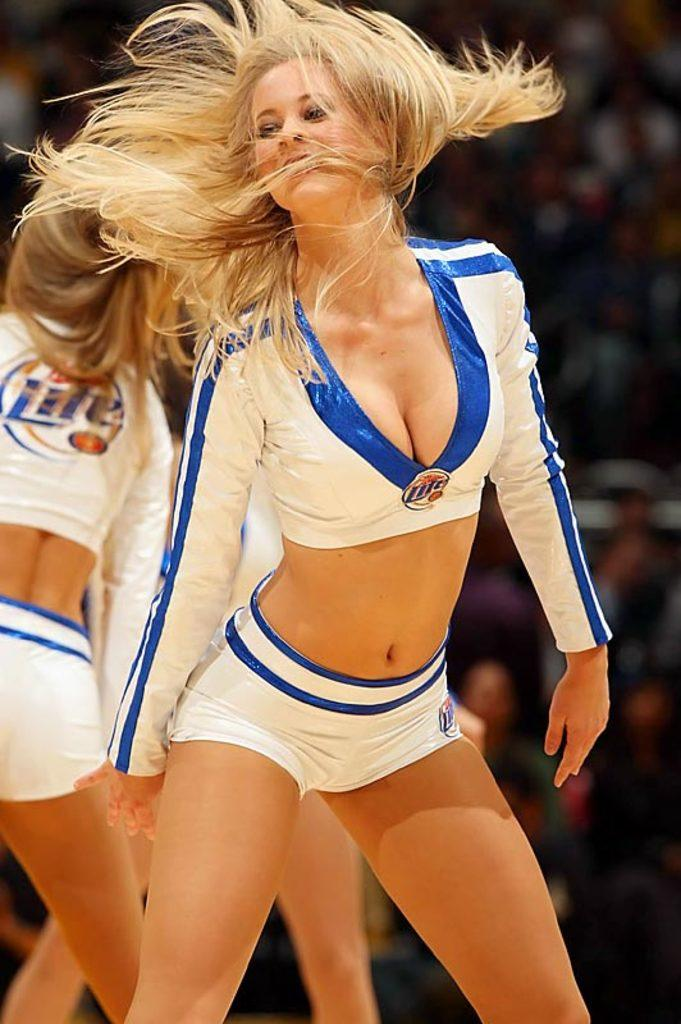<image>
Write a terse but informative summary of the picture. Blonde cheerleaders wear skimpy uniforms with the Miller Lite name on them. 